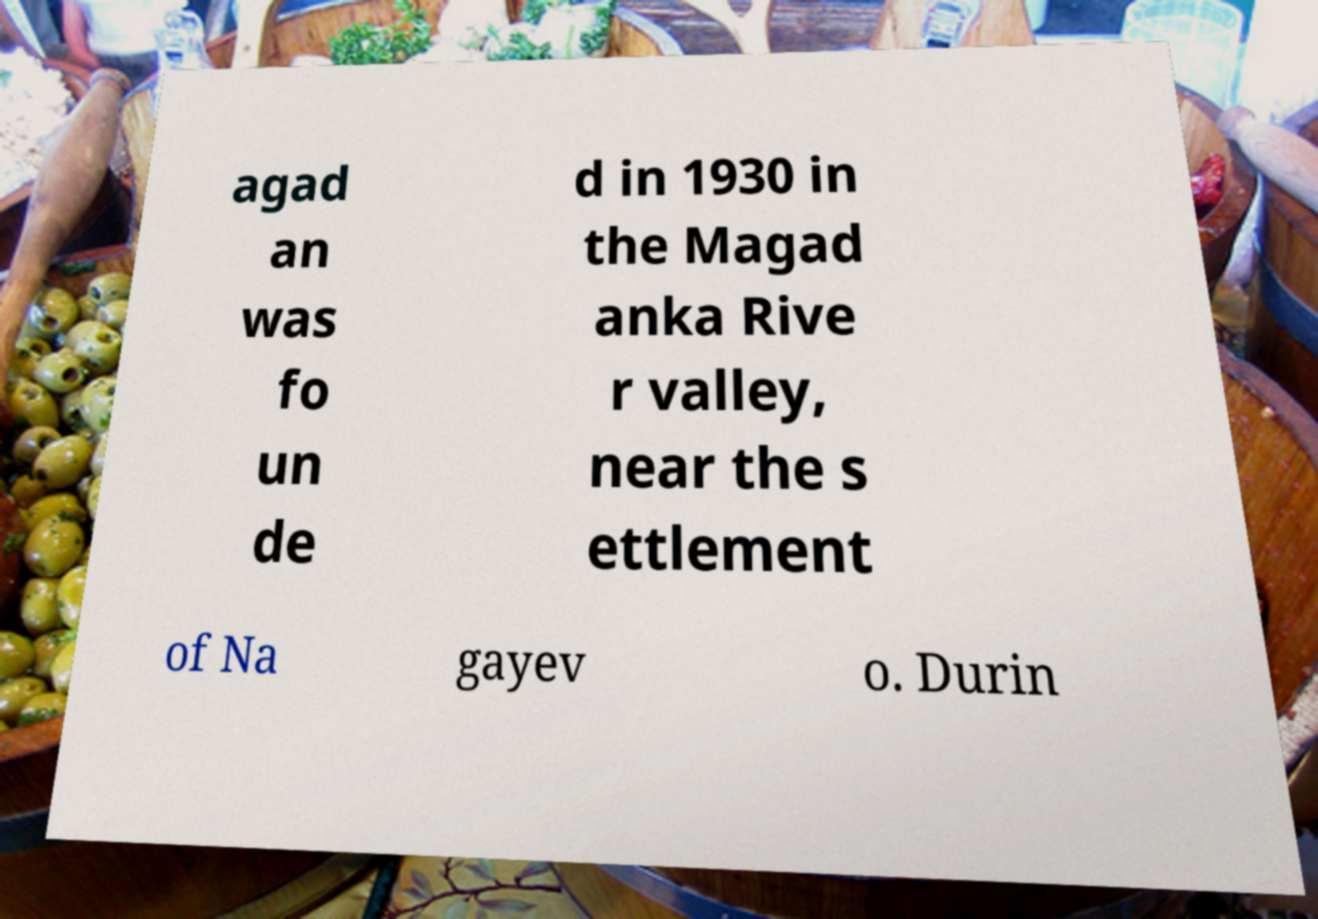What messages or text are displayed in this image? I need them in a readable, typed format. agad an was fo un de d in 1930 in the Magad anka Rive r valley, near the s ettlement of Na gayev o. Durin 